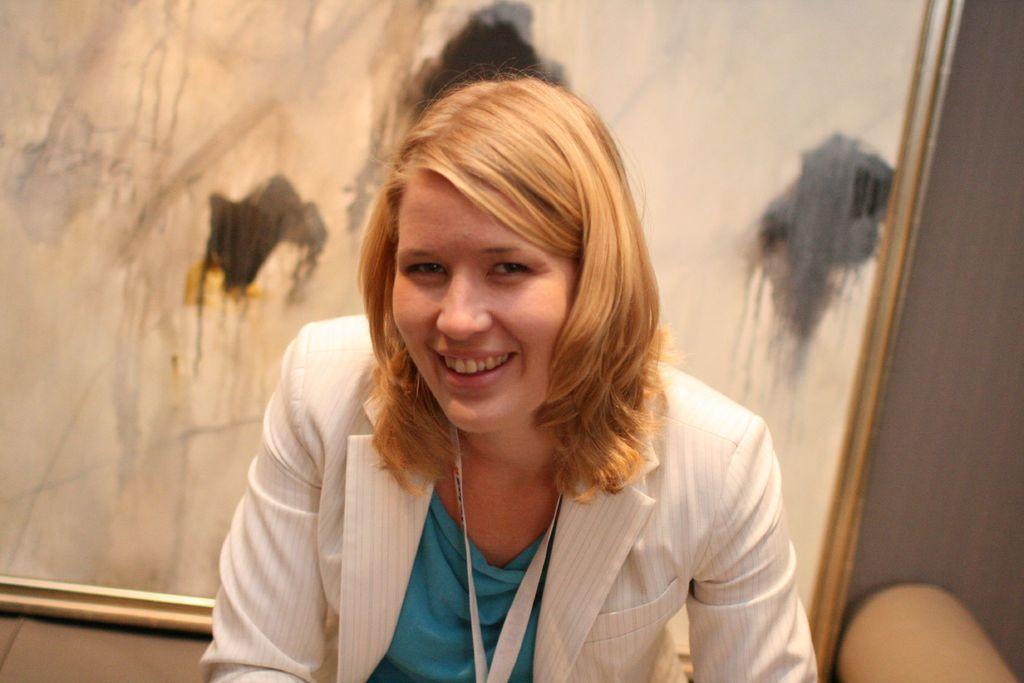Describe this image in one or two sentences. In this image there is a person wearing id card. Beside the person there is an object. And at the background there is a wall and a photo frame. 